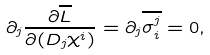Convert formula to latex. <formula><loc_0><loc_0><loc_500><loc_500>\partial _ { j } \frac { \partial \overline { L } } { \partial ( D _ { j } \chi ^ { i } ) } = \partial _ { j } \overline { \sigma ^ { j } _ { i } } = 0 ,</formula> 